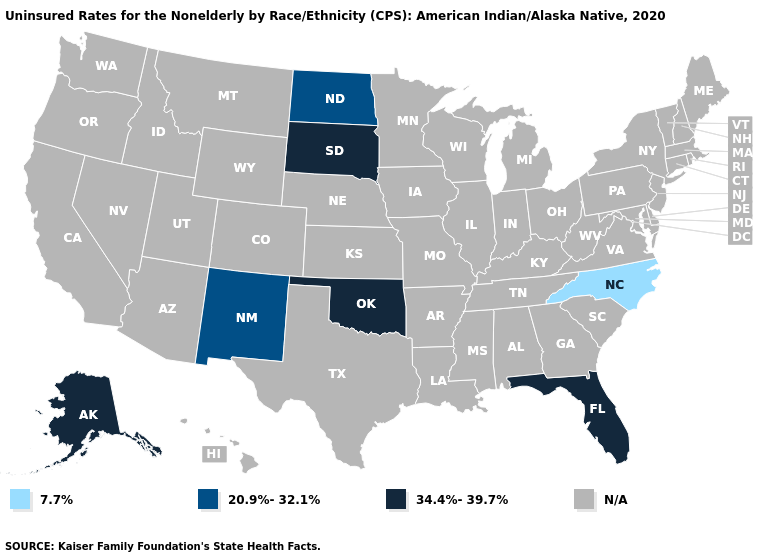What is the lowest value in the West?
Be succinct. 20.9%-32.1%. Does the first symbol in the legend represent the smallest category?
Keep it brief. Yes. What is the value of Nevada?
Keep it brief. N/A. What is the value of Alaska?
Be succinct. 34.4%-39.7%. What is the highest value in the West ?
Be succinct. 34.4%-39.7%. What is the value of Mississippi?
Write a very short answer. N/A. Does the map have missing data?
Give a very brief answer. Yes. Does Florida have the highest value in the USA?
Give a very brief answer. Yes. Which states have the highest value in the USA?
Quick response, please. Alaska, Florida, Oklahoma, South Dakota. What is the value of Wyoming?
Concise answer only. N/A. Which states have the lowest value in the MidWest?
Be succinct. North Dakota. Name the states that have a value in the range 34.4%-39.7%?
Give a very brief answer. Alaska, Florida, Oklahoma, South Dakota. Name the states that have a value in the range 34.4%-39.7%?
Short answer required. Alaska, Florida, Oklahoma, South Dakota. 